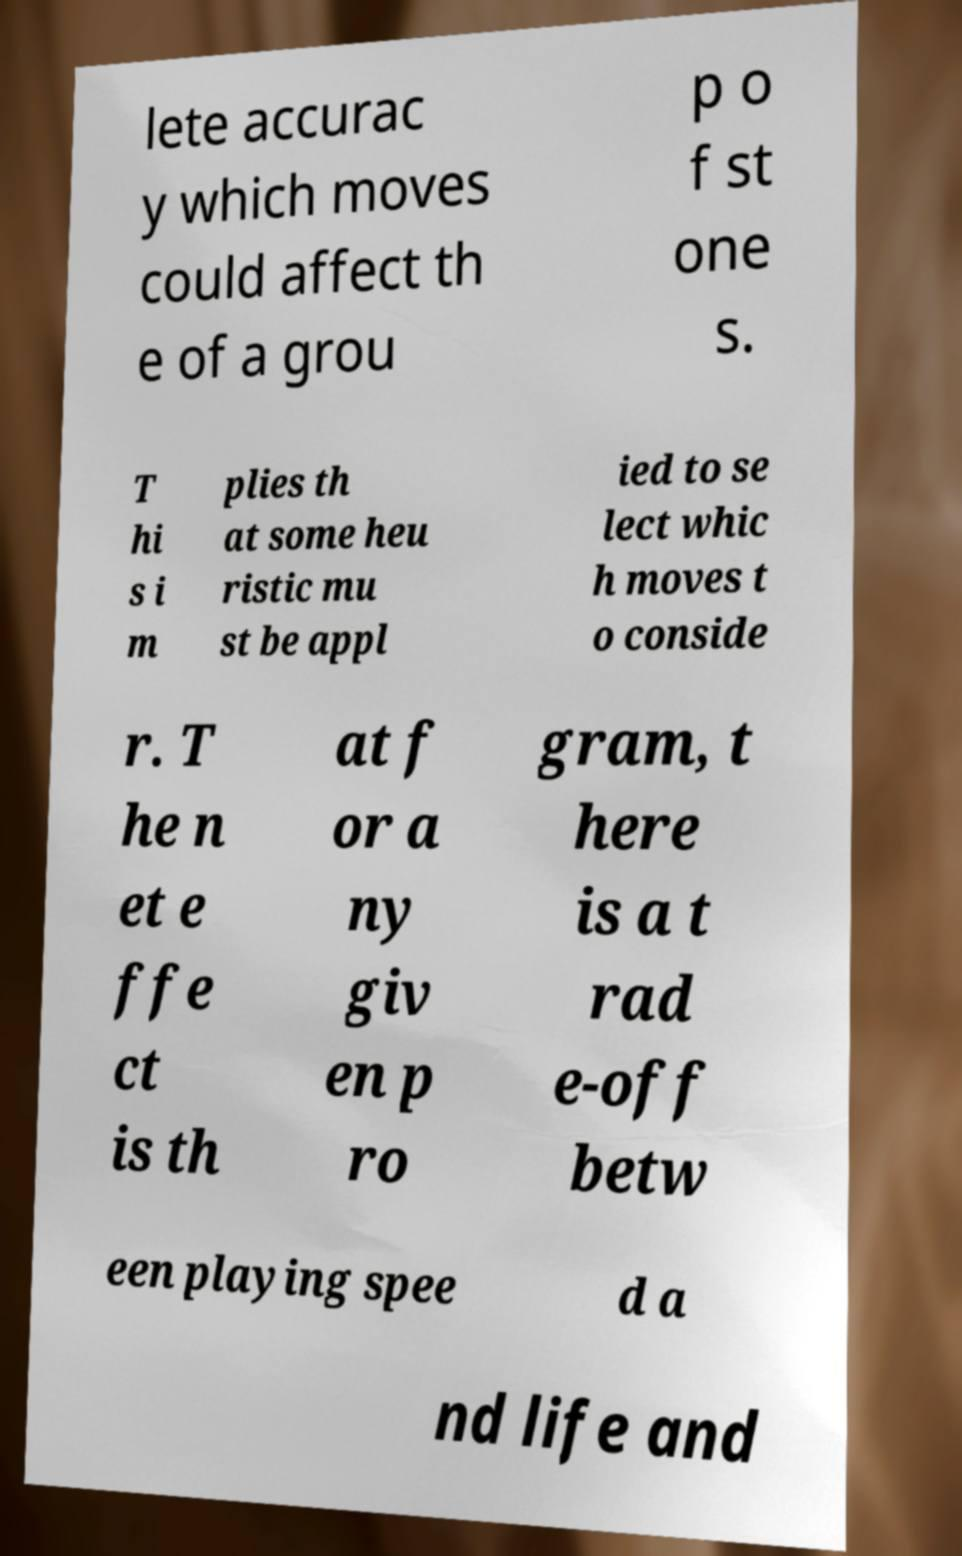Could you extract and type out the text from this image? lete accurac y which moves could affect th e of a grou p o f st one s. T hi s i m plies th at some heu ristic mu st be appl ied to se lect whic h moves t o conside r. T he n et e ffe ct is th at f or a ny giv en p ro gram, t here is a t rad e-off betw een playing spee d a nd life and 